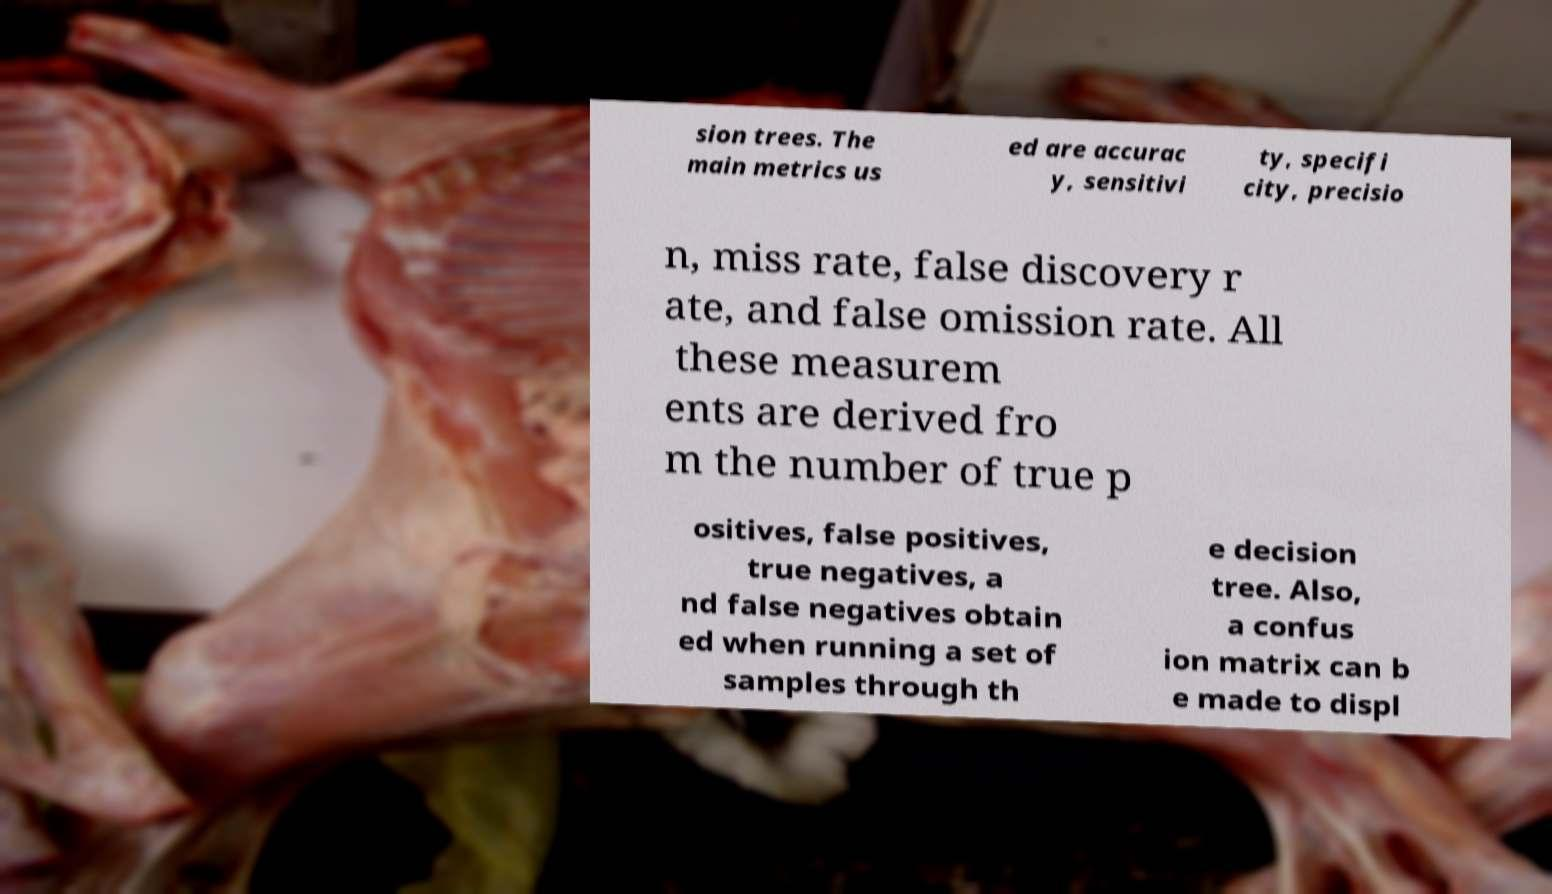Could you extract and type out the text from this image? sion trees. The main metrics us ed are accurac y, sensitivi ty, specifi city, precisio n, miss rate, false discovery r ate, and false omission rate. All these measurem ents are derived fro m the number of true p ositives, false positives, true negatives, a nd false negatives obtain ed when running a set of samples through th e decision tree. Also, a confus ion matrix can b e made to displ 